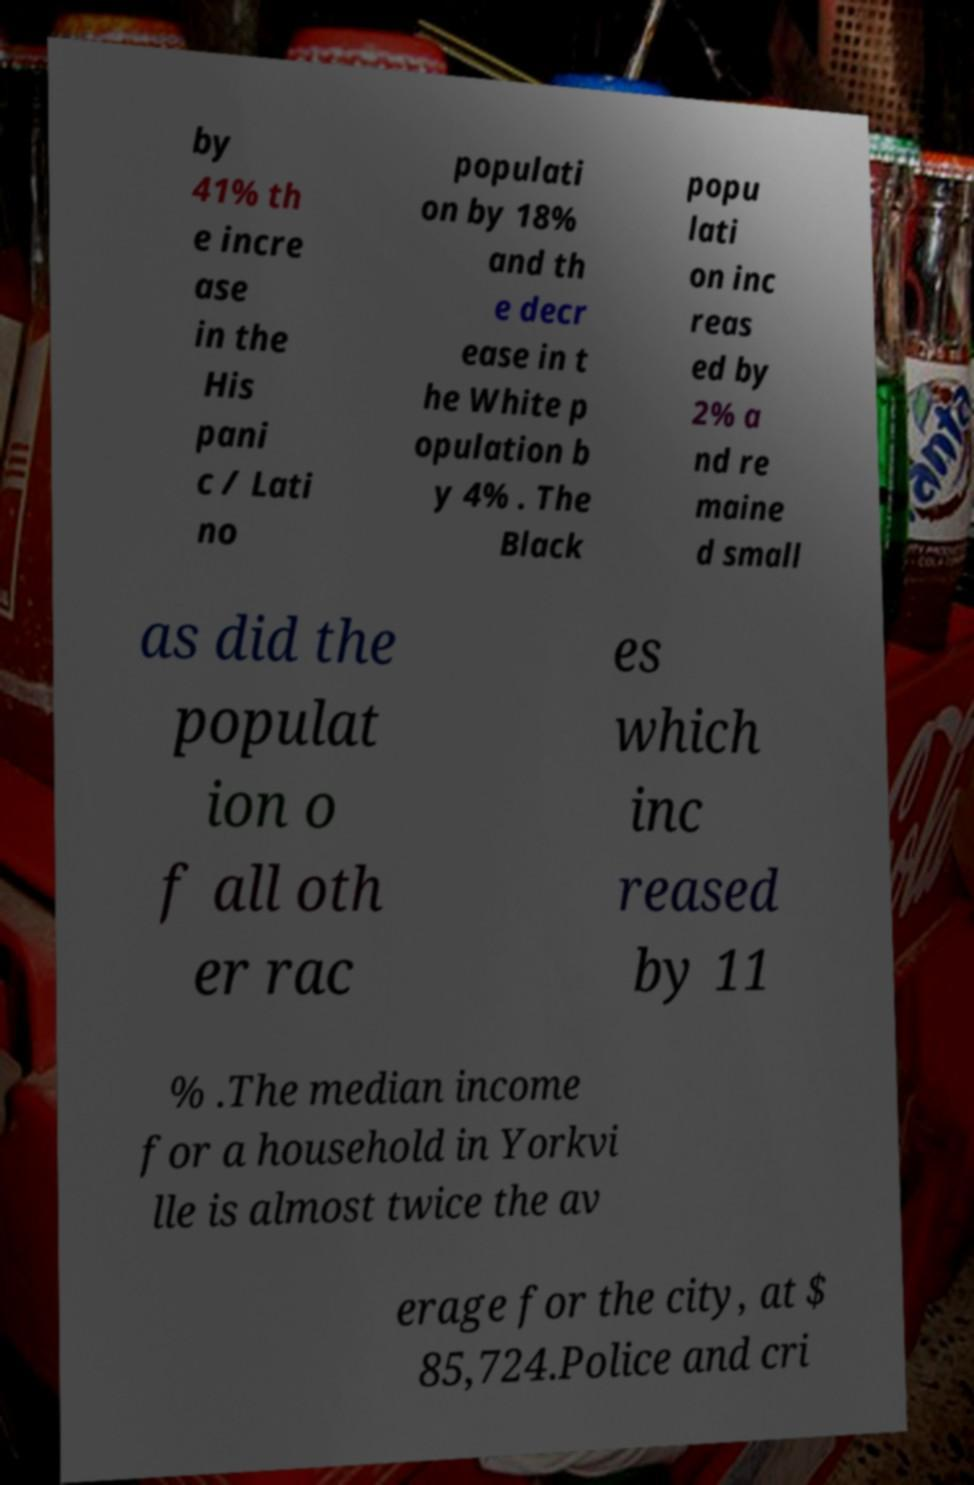Please identify and transcribe the text found in this image. by 41% th e incre ase in the His pani c / Lati no populati on by 18% and th e decr ease in t he White p opulation b y 4% . The Black popu lati on inc reas ed by 2% a nd re maine d small as did the populat ion o f all oth er rac es which inc reased by 11 % .The median income for a household in Yorkvi lle is almost twice the av erage for the city, at $ 85,724.Police and cri 